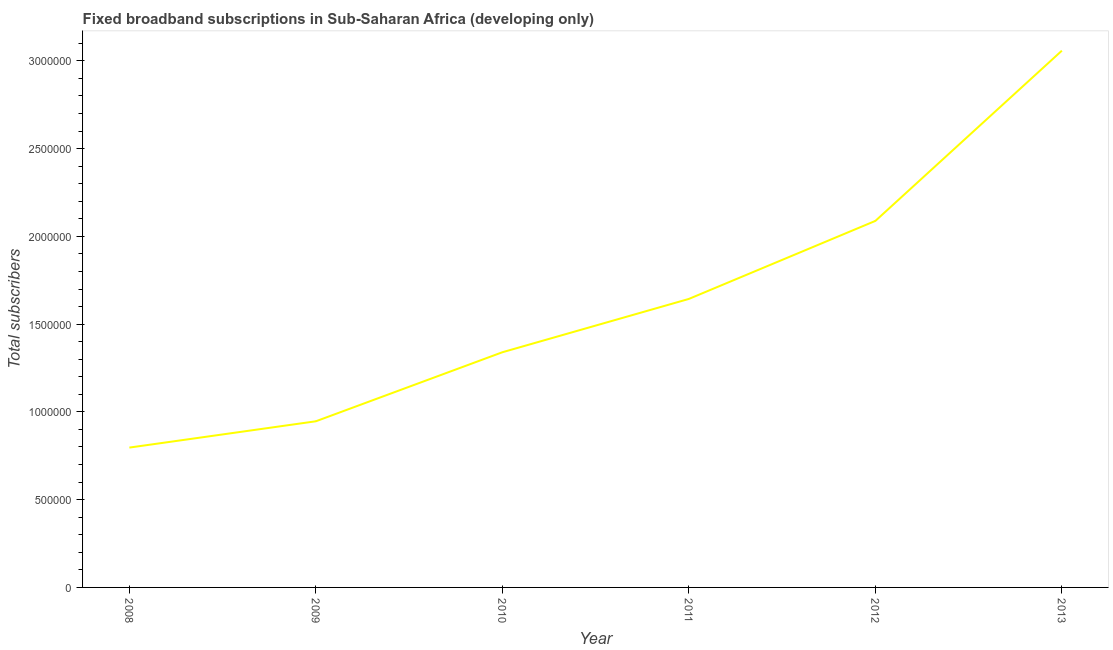What is the total number of fixed broadband subscriptions in 2011?
Provide a short and direct response. 1.64e+06. Across all years, what is the maximum total number of fixed broadband subscriptions?
Your answer should be compact. 3.06e+06. Across all years, what is the minimum total number of fixed broadband subscriptions?
Your answer should be compact. 7.97e+05. What is the sum of the total number of fixed broadband subscriptions?
Your answer should be very brief. 9.87e+06. What is the difference between the total number of fixed broadband subscriptions in 2010 and 2012?
Provide a succinct answer. -7.48e+05. What is the average total number of fixed broadband subscriptions per year?
Your answer should be compact. 1.65e+06. What is the median total number of fixed broadband subscriptions?
Give a very brief answer. 1.49e+06. What is the ratio of the total number of fixed broadband subscriptions in 2009 to that in 2013?
Provide a succinct answer. 0.31. Is the total number of fixed broadband subscriptions in 2010 less than that in 2011?
Your answer should be very brief. Yes. What is the difference between the highest and the second highest total number of fixed broadband subscriptions?
Make the answer very short. 9.70e+05. Is the sum of the total number of fixed broadband subscriptions in 2008 and 2009 greater than the maximum total number of fixed broadband subscriptions across all years?
Your answer should be compact. No. What is the difference between the highest and the lowest total number of fixed broadband subscriptions?
Offer a terse response. 2.26e+06. In how many years, is the total number of fixed broadband subscriptions greater than the average total number of fixed broadband subscriptions taken over all years?
Offer a very short reply. 2. Does the total number of fixed broadband subscriptions monotonically increase over the years?
Keep it short and to the point. Yes. How many lines are there?
Give a very brief answer. 1. How many years are there in the graph?
Offer a very short reply. 6. What is the difference between two consecutive major ticks on the Y-axis?
Make the answer very short. 5.00e+05. Are the values on the major ticks of Y-axis written in scientific E-notation?
Your answer should be compact. No. What is the title of the graph?
Make the answer very short. Fixed broadband subscriptions in Sub-Saharan Africa (developing only). What is the label or title of the X-axis?
Provide a short and direct response. Year. What is the label or title of the Y-axis?
Provide a succinct answer. Total subscribers. What is the Total subscribers of 2008?
Give a very brief answer. 7.97e+05. What is the Total subscribers of 2009?
Offer a terse response. 9.47e+05. What is the Total subscribers in 2010?
Provide a short and direct response. 1.34e+06. What is the Total subscribers in 2011?
Provide a short and direct response. 1.64e+06. What is the Total subscribers in 2012?
Offer a terse response. 2.09e+06. What is the Total subscribers of 2013?
Your response must be concise. 3.06e+06. What is the difference between the Total subscribers in 2008 and 2009?
Make the answer very short. -1.50e+05. What is the difference between the Total subscribers in 2008 and 2010?
Make the answer very short. -5.43e+05. What is the difference between the Total subscribers in 2008 and 2011?
Keep it short and to the point. -8.47e+05. What is the difference between the Total subscribers in 2008 and 2012?
Your response must be concise. -1.29e+06. What is the difference between the Total subscribers in 2008 and 2013?
Provide a short and direct response. -2.26e+06. What is the difference between the Total subscribers in 2009 and 2010?
Your answer should be compact. -3.93e+05. What is the difference between the Total subscribers in 2009 and 2011?
Ensure brevity in your answer.  -6.97e+05. What is the difference between the Total subscribers in 2009 and 2012?
Make the answer very short. -1.14e+06. What is the difference between the Total subscribers in 2009 and 2013?
Keep it short and to the point. -2.11e+06. What is the difference between the Total subscribers in 2010 and 2011?
Your answer should be very brief. -3.04e+05. What is the difference between the Total subscribers in 2010 and 2012?
Provide a short and direct response. -7.48e+05. What is the difference between the Total subscribers in 2010 and 2013?
Offer a very short reply. -1.72e+06. What is the difference between the Total subscribers in 2011 and 2012?
Make the answer very short. -4.44e+05. What is the difference between the Total subscribers in 2011 and 2013?
Your answer should be very brief. -1.41e+06. What is the difference between the Total subscribers in 2012 and 2013?
Your response must be concise. -9.70e+05. What is the ratio of the Total subscribers in 2008 to that in 2009?
Ensure brevity in your answer.  0.84. What is the ratio of the Total subscribers in 2008 to that in 2010?
Your response must be concise. 0.59. What is the ratio of the Total subscribers in 2008 to that in 2011?
Give a very brief answer. 0.48. What is the ratio of the Total subscribers in 2008 to that in 2012?
Make the answer very short. 0.38. What is the ratio of the Total subscribers in 2008 to that in 2013?
Make the answer very short. 0.26. What is the ratio of the Total subscribers in 2009 to that in 2010?
Keep it short and to the point. 0.71. What is the ratio of the Total subscribers in 2009 to that in 2011?
Your answer should be very brief. 0.58. What is the ratio of the Total subscribers in 2009 to that in 2012?
Give a very brief answer. 0.45. What is the ratio of the Total subscribers in 2009 to that in 2013?
Provide a short and direct response. 0.31. What is the ratio of the Total subscribers in 2010 to that in 2011?
Provide a succinct answer. 0.81. What is the ratio of the Total subscribers in 2010 to that in 2012?
Your answer should be very brief. 0.64. What is the ratio of the Total subscribers in 2010 to that in 2013?
Provide a short and direct response. 0.44. What is the ratio of the Total subscribers in 2011 to that in 2012?
Give a very brief answer. 0.79. What is the ratio of the Total subscribers in 2011 to that in 2013?
Offer a very short reply. 0.54. What is the ratio of the Total subscribers in 2012 to that in 2013?
Offer a very short reply. 0.68. 